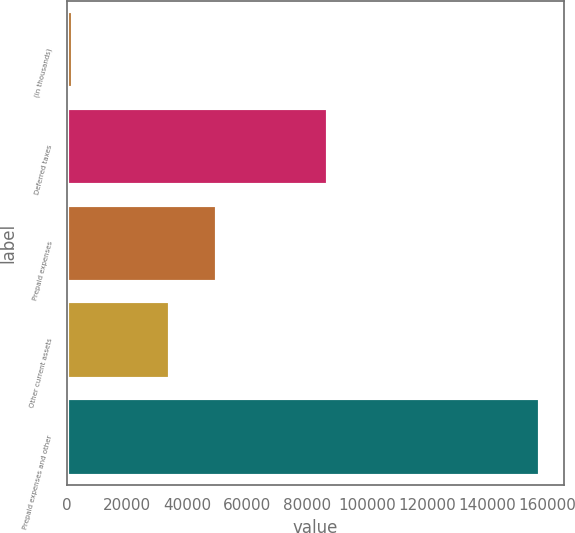Convert chart. <chart><loc_0><loc_0><loc_500><loc_500><bar_chart><fcel>(in thousands)<fcel>Deferred taxes<fcel>Prepaid expenses<fcel>Other current assets<fcel>Prepaid expenses and other<nl><fcel>2013<fcel>86929<fcel>49976.4<fcel>34429<fcel>157487<nl></chart> 